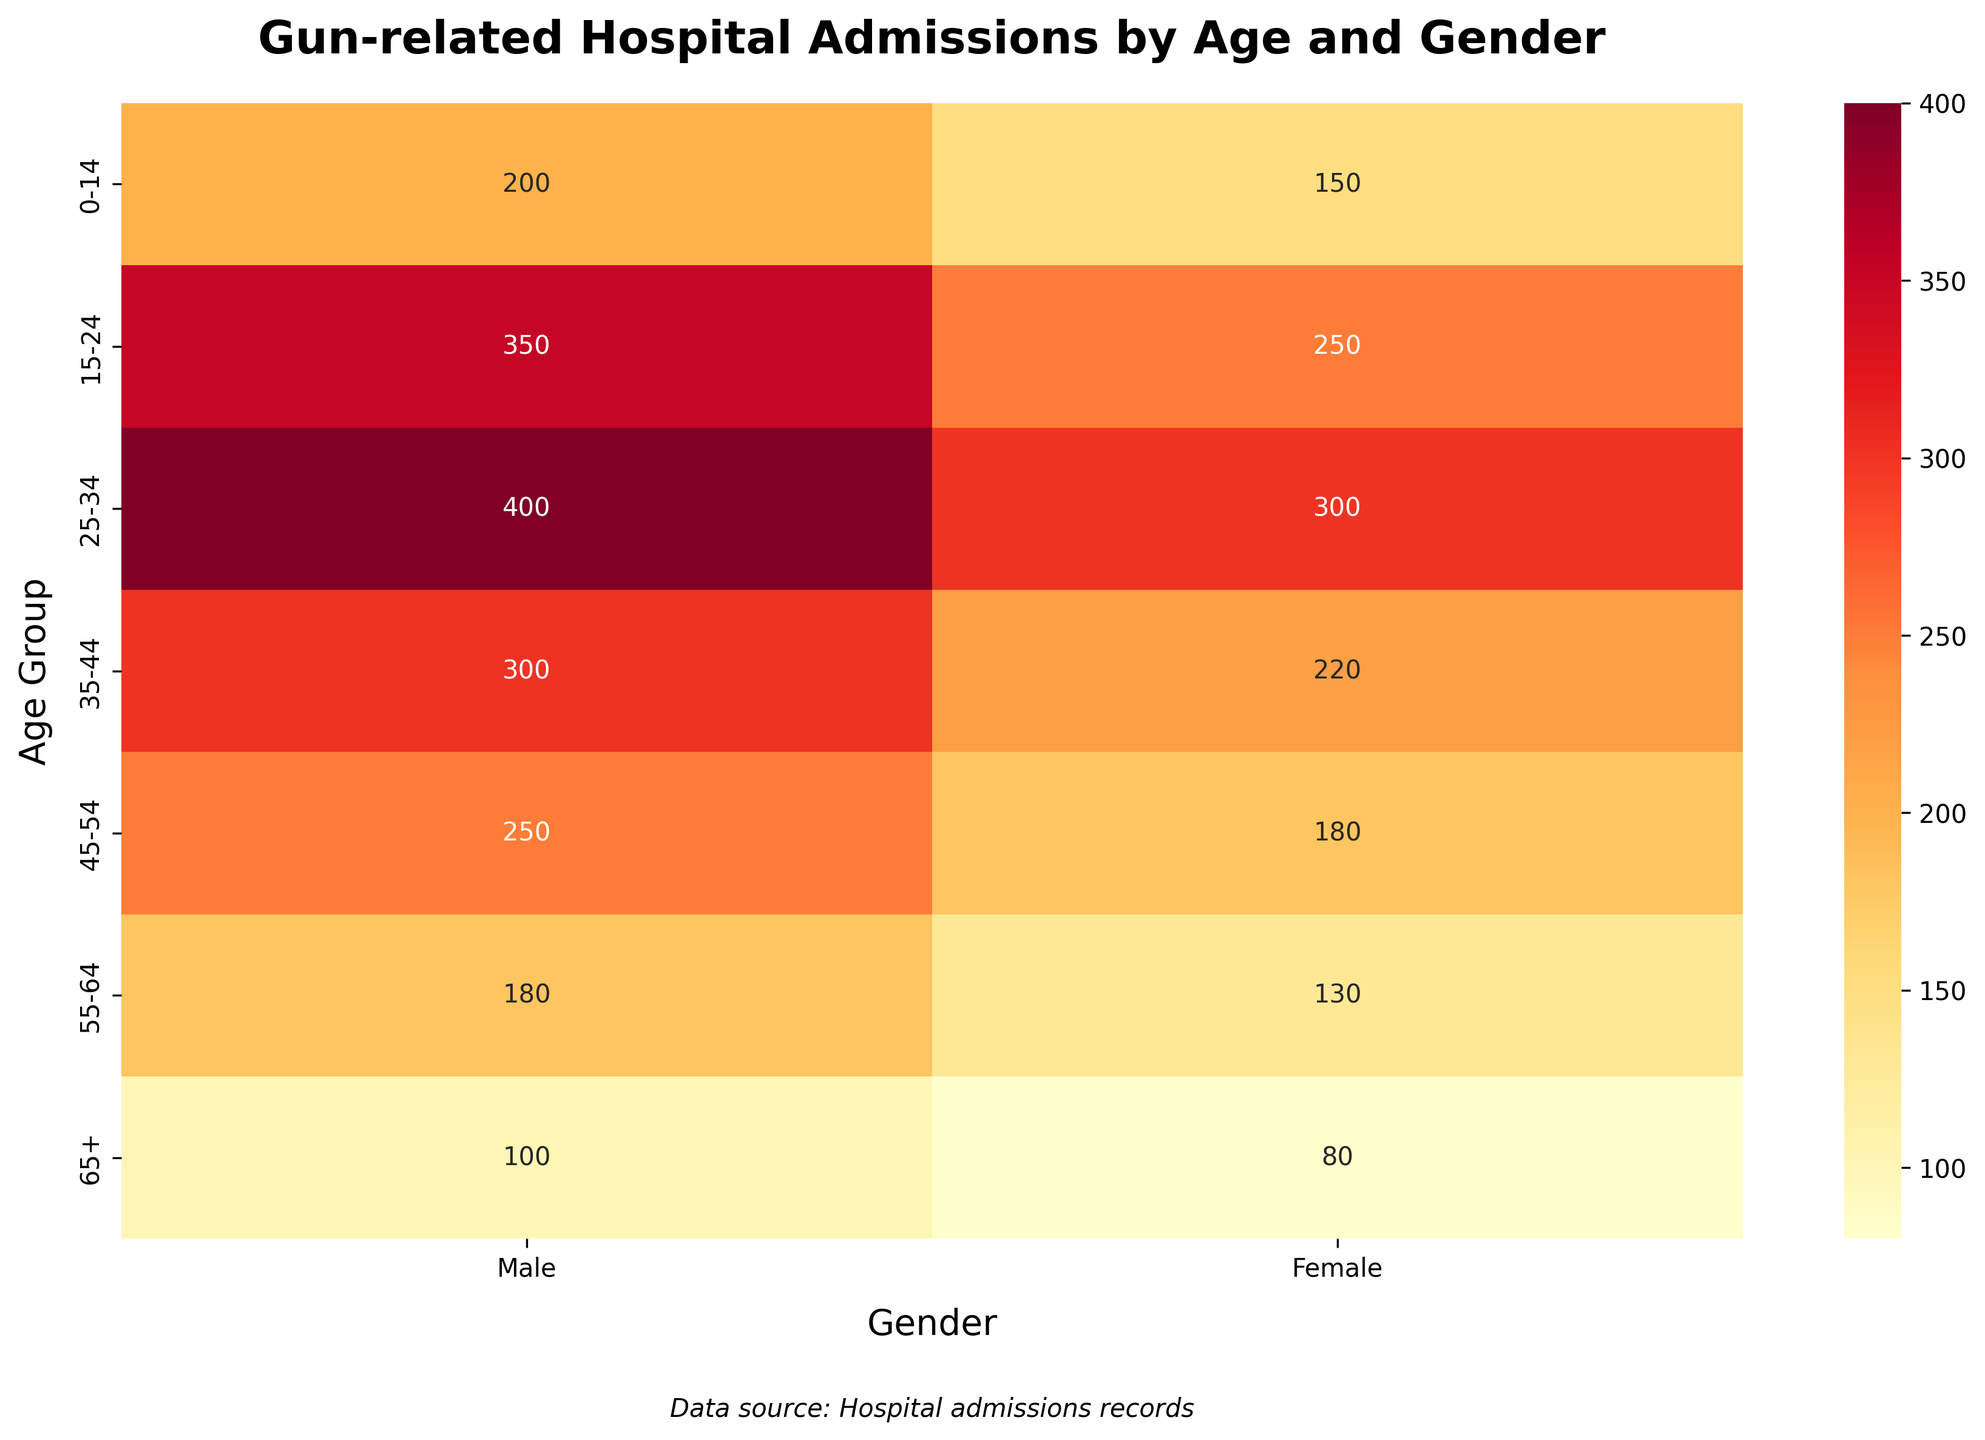What's the title of the heatmap? The title of the heatmap is written at the top of the figure. It provides an overview of what the visual representation is about.
Answer: Gun-related Hospital Admissions by Age and Gender What age group and gender combination has the highest number of hospital admissions? By examining the color intensity and the annotations on the heatmap, we can identify that the "25-34, Male" combination has the highest admission number. It is marked with the darkest shade and the highest numerical value.
Answer: 25-34, Male What is the difference in the number of hospital admissions between the age groups 15-24 and 35-44 for males? To find the difference, locate the values for males in the age groups 15-24 and 35-44. Subtract the value for 35-44 (300) from the value for 15-24 (350).
Answer: 50 How do the number of admissions compare between females aged 0-14 and females aged 65+? Look at the heatmap and refer to the values for females in the age groups 0-14 and 65+. Compare the numbers directly. The value for females aged 0-14 is 150 and for females aged 65+ is 80.
Answer: Females aged 0-14 have 70 more admissions than females aged 65+ What is the overall trend in the number of hospital admissions from the youngest to oldest age group for males? By observing the values for males as you move from the youngest to the oldest age group, we see a peak in admissions in the 25-34 age group. After 25-34, the admissions decrease with age.
Answer: Peak in 25-34, then decrease Which age group has the smallest gender gap in hospital admissions? Calculate the difference between male and female admissions for each age group. The smallest difference is in the age group 55-64, where males have 180 admissions and females have 130, a difference of 50.
Answer: 55-64 What are the total admissions for the age group 15-24? To get the total for 15-24, sum the values for males (350) and females (250) in this age group.
Answer: 600 Which gender shows more admissions in the age group 45-54? Compare the values for males (250) and females (180) in the age group 45-54. Males have a higher number of admissions.
Answer: Male What's the average number of hospital admissions for females across all age groups? Sum the values for females in each age group (150 + 250 + 300 + 220 + 180 + 130 + 80) and divide by the number of age groups (7).
Answer: 187.14 